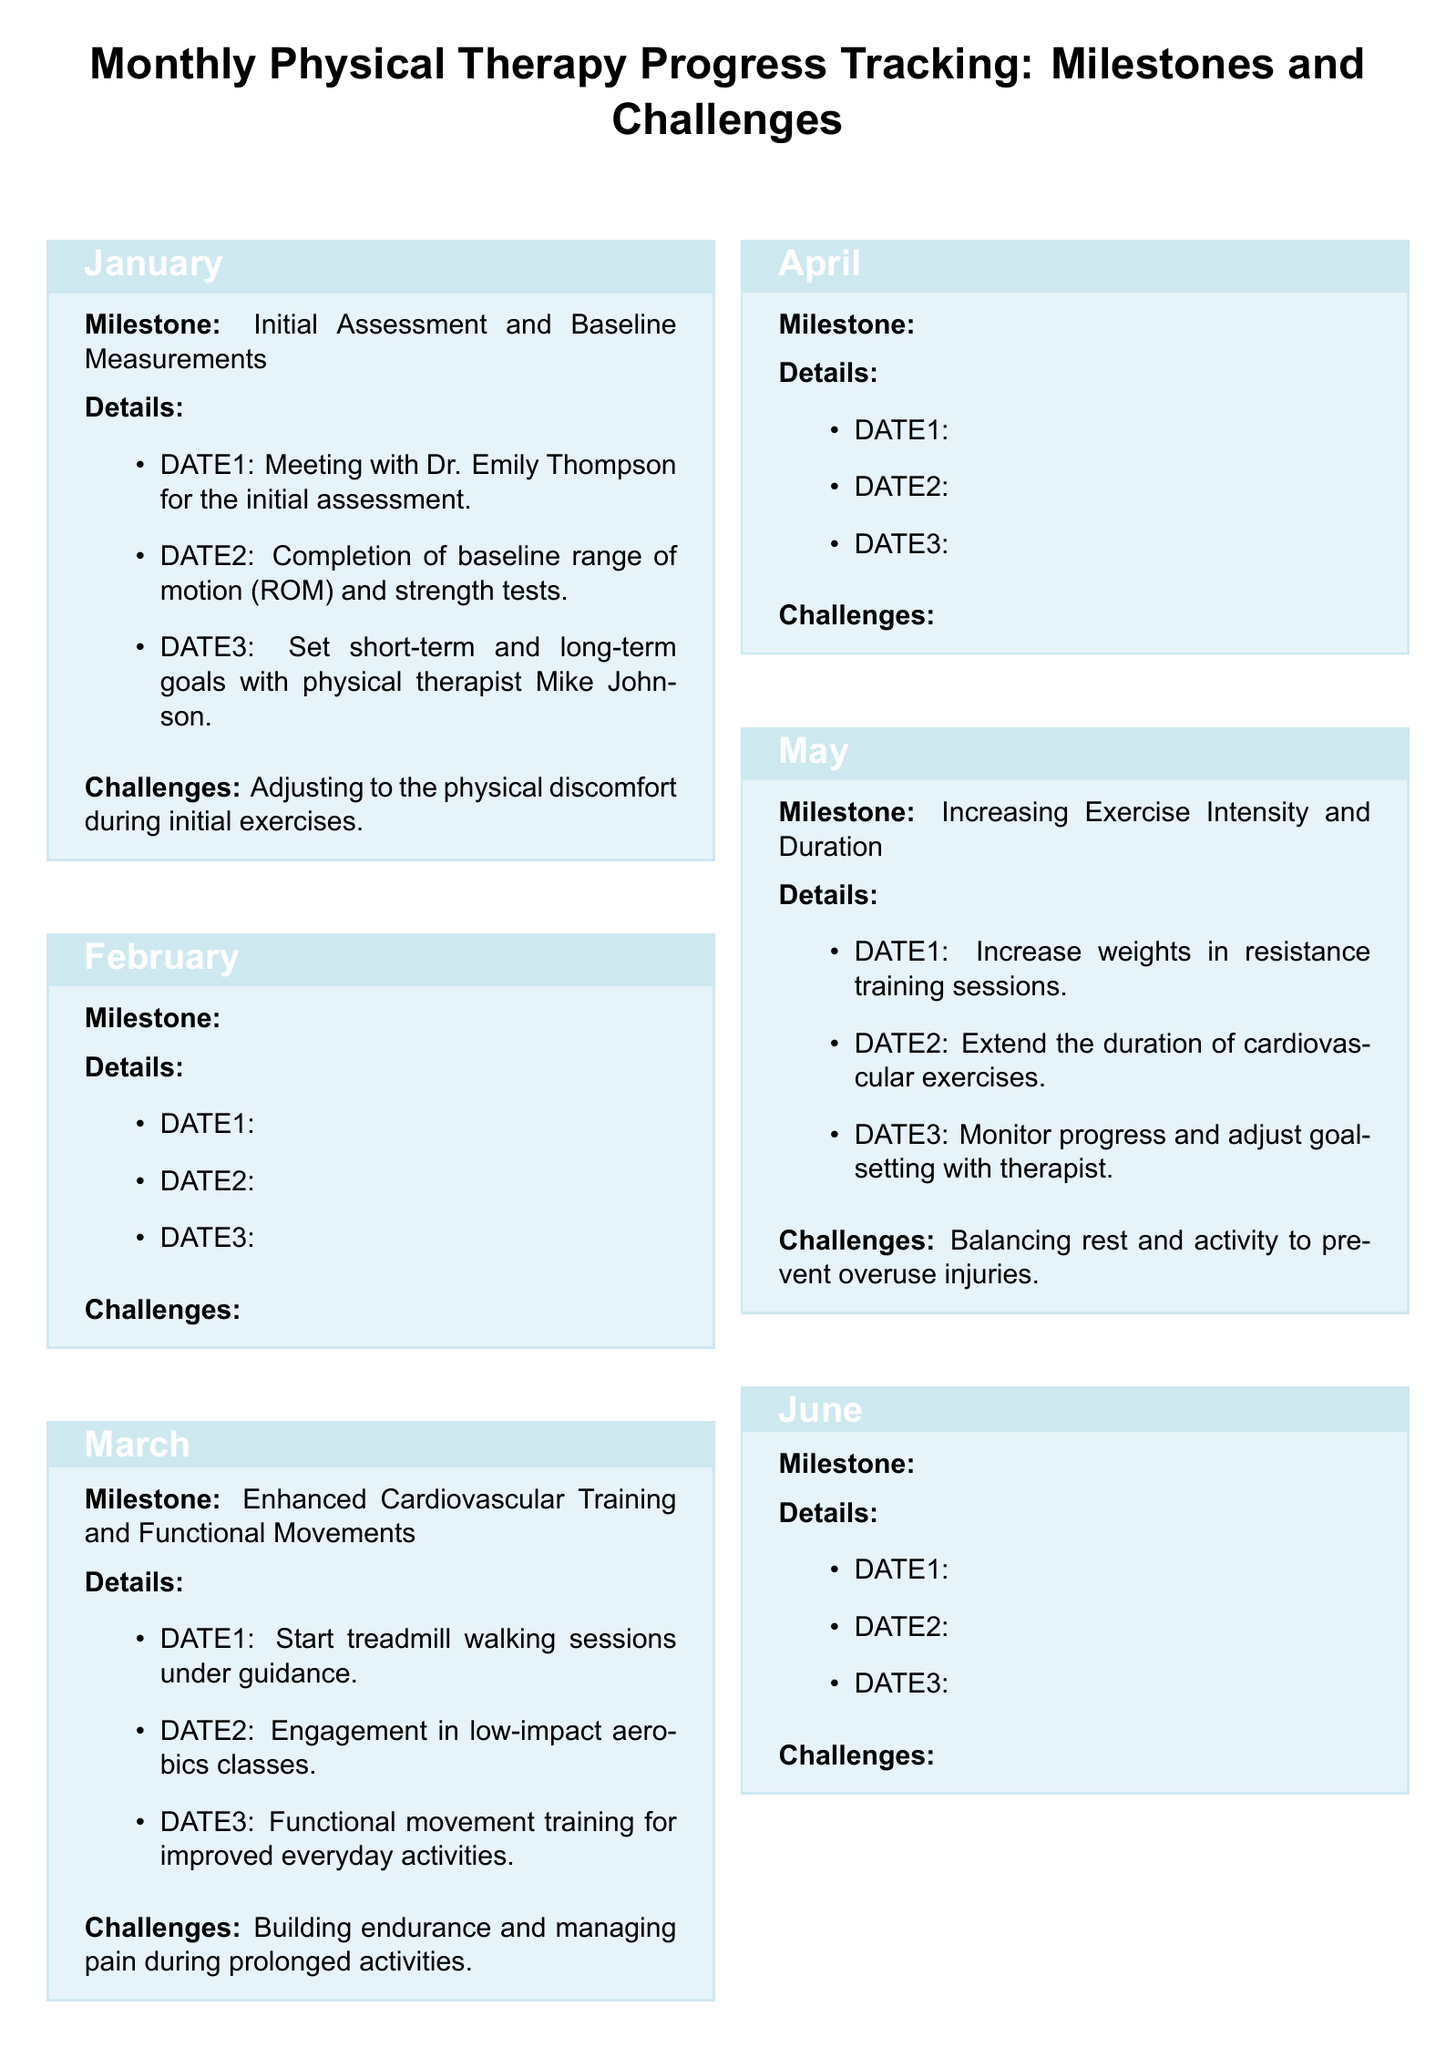What is the milestone for January? The milestone for January is the initial assessment and baseline measurements, which is specified in the document.
Answer: Initial Assessment and Baseline Measurements What exercise type was introduced in February? The document states that strengthening and flexibility exercises were introduced in February.
Answer: Strengthening and Flexibility Exercises What is a challenge listed for March? The document mentions "building endurance and managing pain during prolonged activities" as a challenge for March.
Answer: Building endurance and managing pain during prolonged activities How many milestones are listed in total? The document outlines six distinct milestones, one for each month from January to June.
Answer: 6 Who conducted the initial assessment? According to the document, Dr. Emily Thompson was involved in conducting the initial assessment.
Answer: Dr. Emily Thompson What is the theme of the personal note section? The personal note emphasizes inspiration by resilience and a desire to pursue a career in medicine after recovery.
Answer: Inspiration by resilience and pursuing a career in medicine In which month was the first session of resistance band exercises held? The document indicates that the first session of resistance band exercises took place in February.
Answer: February What month is associated with increased exercise intensity? The document specifies that the milestone for increasing exercise intensity and duration occurs in May.
Answer: May 